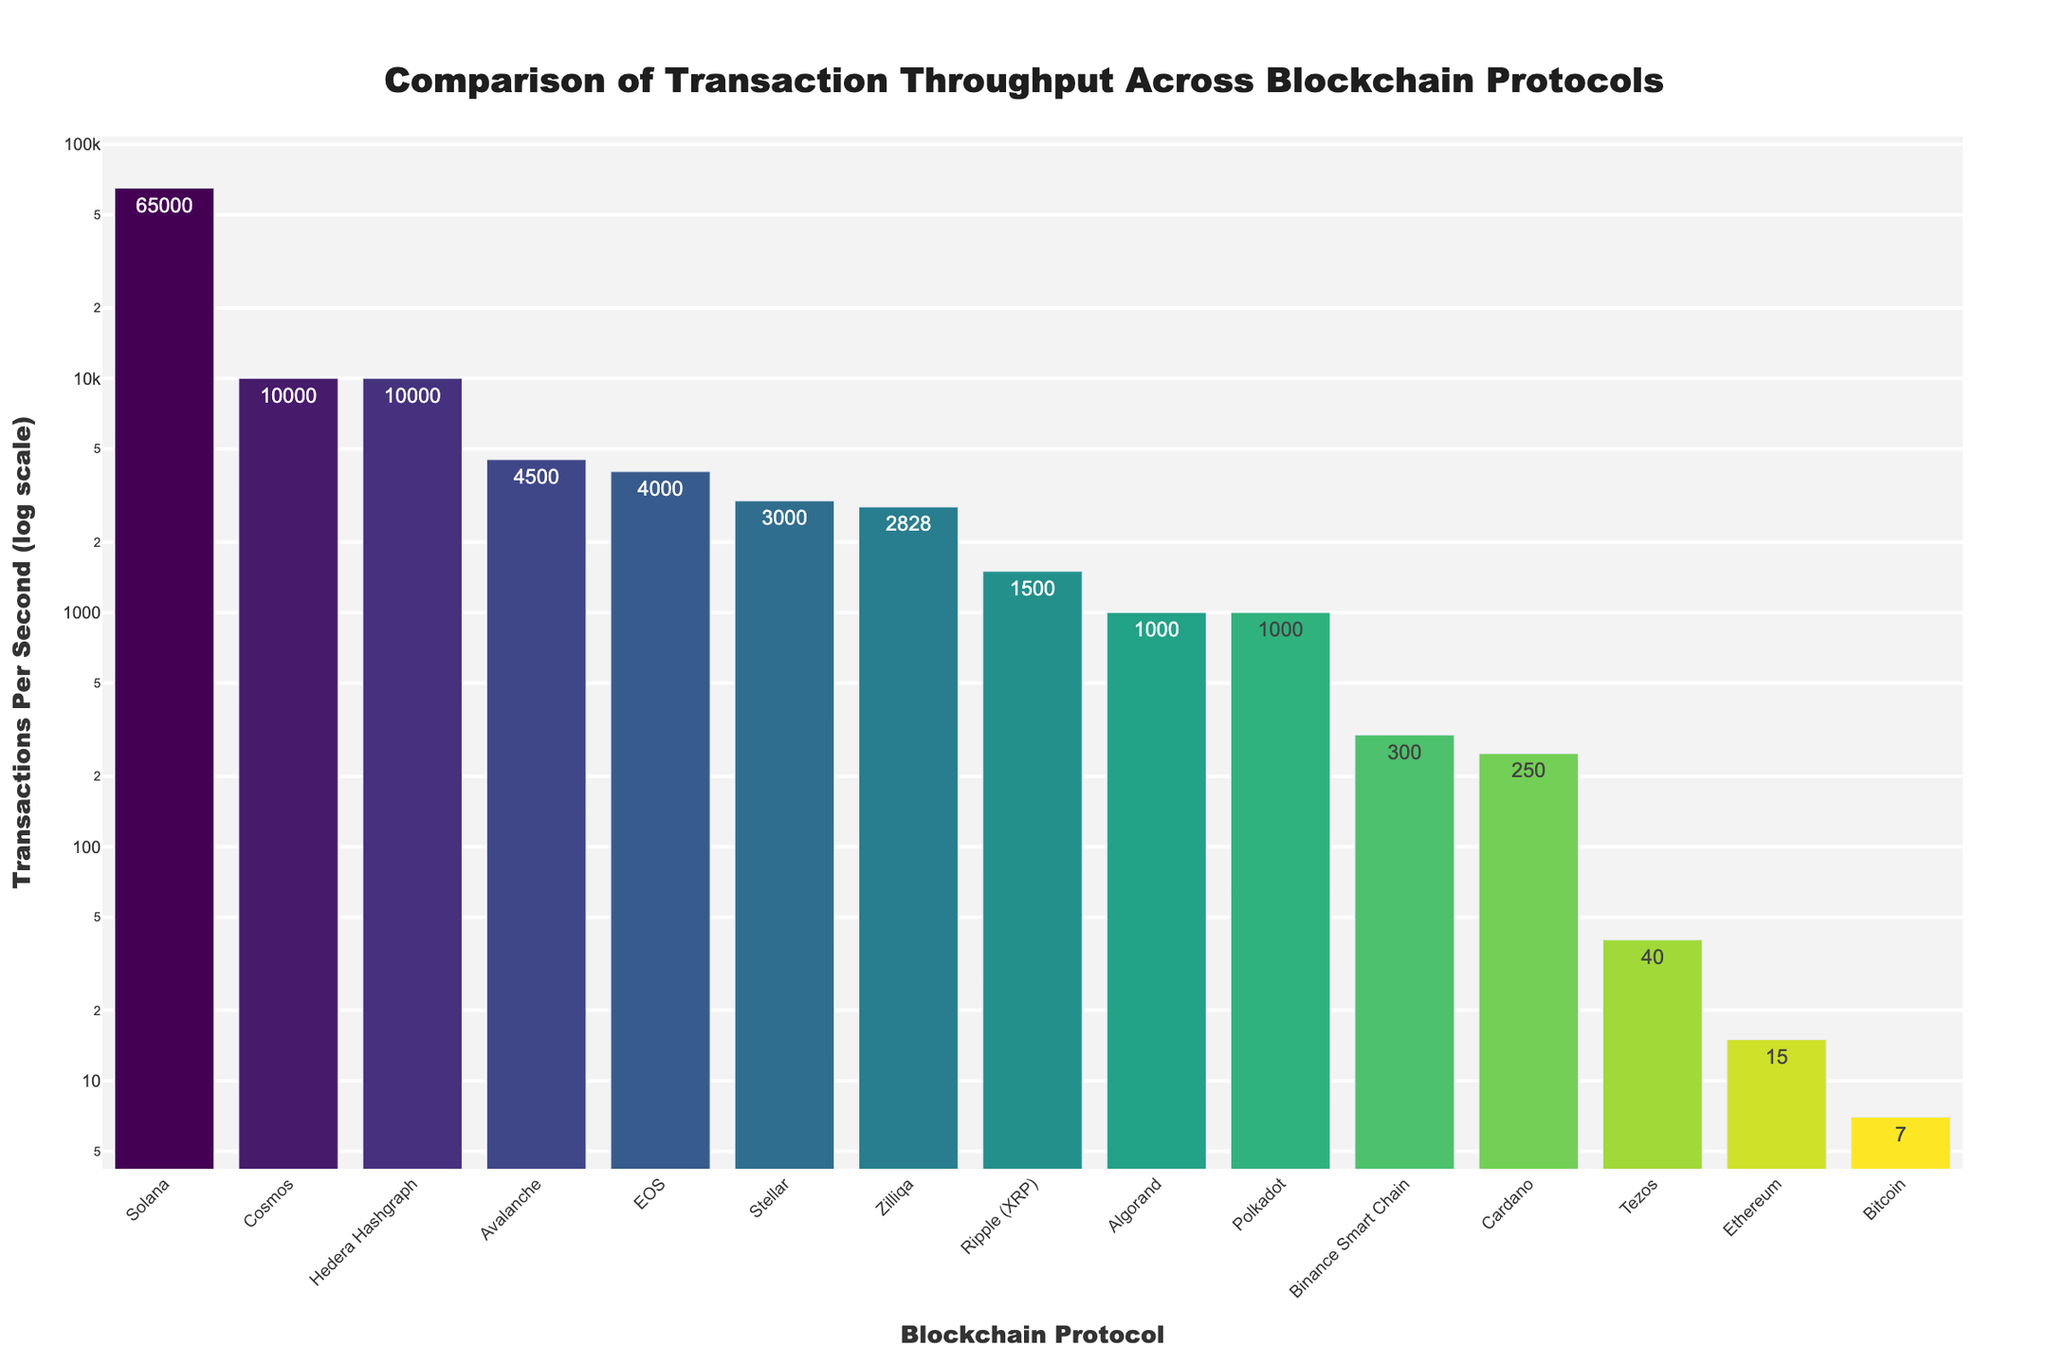Which blockchain protocol has the highest transaction throughput? By examining the tallest bar and its label, we can identify the protocol with the highest transactions per second. The tallest bar corresponds to Solana with 65,000 transactions per second.
Answer: Solana Which blockchain protocol has the lowest transaction throughput? By observing the shortest bar and its label, we find that Bitcoin, with 7 transactions per second, has the lowest transaction throughput.
Answer: Bitcoin How does the transaction throughput of Ripple (XRP) compare to Ethereum? Check the heights of the bars for Ripple (XRP) and Ethereum. Ripple (XRP) has 1500 transactions per second while Ethereum has 15 transactions per second. Ripple (XRP) has significantly higher throughput than Ethereum.
Answer: Ripple (XRP) is greater What is the sum of transaction throughputs for Bitcoin, Ethereum, and Tezos? Add the transactions per second values for Bitcoin (7), Ethereum (15), and Tezos (40). The sum is 7 + 15 + 40 = 62.
Answer: 62 Which blockchain protocols have a transaction throughput greater than 5,000 transactions per second? Identify bars with heights indicating more than 5,000 transactions per second: Solana (65,000), Cosmos (10,000), and Hedera Hashgraph (10,000).
Answer: Solana, Cosmos, Hedera Hashgraph What is the difference in transaction throughput between Binance Smart Chain and Cardano? Subtract the transactions per second for Binance Smart Chain (300) from that of Cardano (250). The difference is 300 - 250 = 50.
Answer: 50 Rank the top three blockchain protocols by transaction throughput. Rank the protocols by examining the heights of the bars in descending order. The top three are Solana (65,000), Cosmos (10,000), and Hedera Hashgraph (10,000).
Answer: Solana, Cosmos, Hedera Hashgraph How many blockchain protocols have more than 1,000 but less than 10,000 transactions per second? Count the number of bars that fall between these values. EOS (4,000), Avalanche (4,500), Zilliqa (2,828), and Ripple (XRP) (1,500), resulting in 4 protocols.
Answer: 4 What is the average transaction throughput of Algorand, Stellar, and Polkadot? Sum the transactions per second values for Algorand (1,000), Stellar (3,000), and Polkadot (1,000). Divide by the number of protocols: (1,000 + 3,000 + 1,000) / 3 = 5,000 / 3 ≈ 1667.
Answer: Approximately 1667 Which blockchain protocol has a transaction throughput closest to 5000 transactions per second? Identify the protocol with the throughput closest to 5,000 by looking at the bar heights. Avalanche, with a transaction throughput of 4,500, is the closest.
Answer: Avalanche 